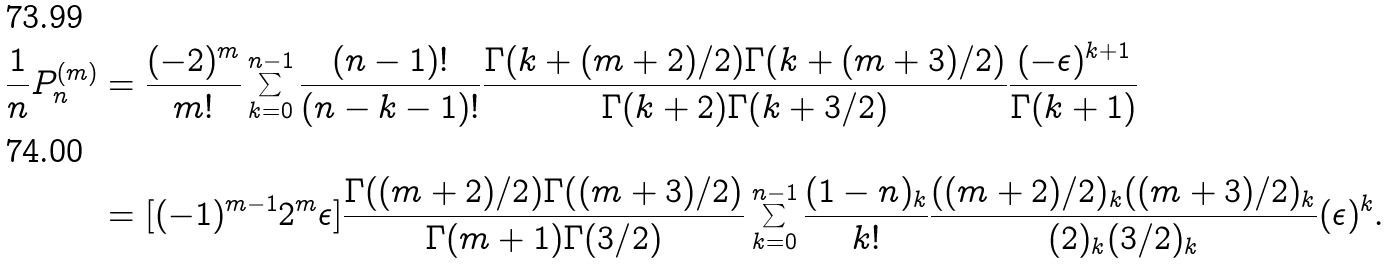<formula> <loc_0><loc_0><loc_500><loc_500>\frac { 1 } { n } P _ { n } ^ { ( m ) } & = \frac { ( - 2 ) ^ { m } } { m ! } \sum _ { k = 0 } ^ { n - 1 } \frac { ( n - 1 ) ! } { ( n - k - 1 ) ! } \frac { \Gamma ( k + ( m + 2 ) / 2 ) \Gamma ( k + ( m + 3 ) / 2 ) } { \Gamma ( k + 2 ) \Gamma ( k + 3 / 2 ) } \frac { ( - \epsilon ) ^ { k + 1 } } { \Gamma ( k + 1 ) } \\ & = [ ( - 1 ) ^ { m - 1 } 2 ^ { m } \epsilon ] \frac { \Gamma ( ( m + 2 ) / 2 ) \Gamma ( ( m + 3 ) / 2 ) } { \Gamma ( m + 1 ) \Gamma ( 3 / 2 ) } \sum _ { k = 0 } ^ { n - 1 } \frac { ( 1 - n ) _ { k } } { k ! } \frac { ( ( m + 2 ) / 2 ) _ { k } ( ( m + 3 ) / 2 ) _ { k } } { ( 2 ) _ { k } ( 3 / 2 ) _ { k } } ( \epsilon ) ^ { k } .</formula> 